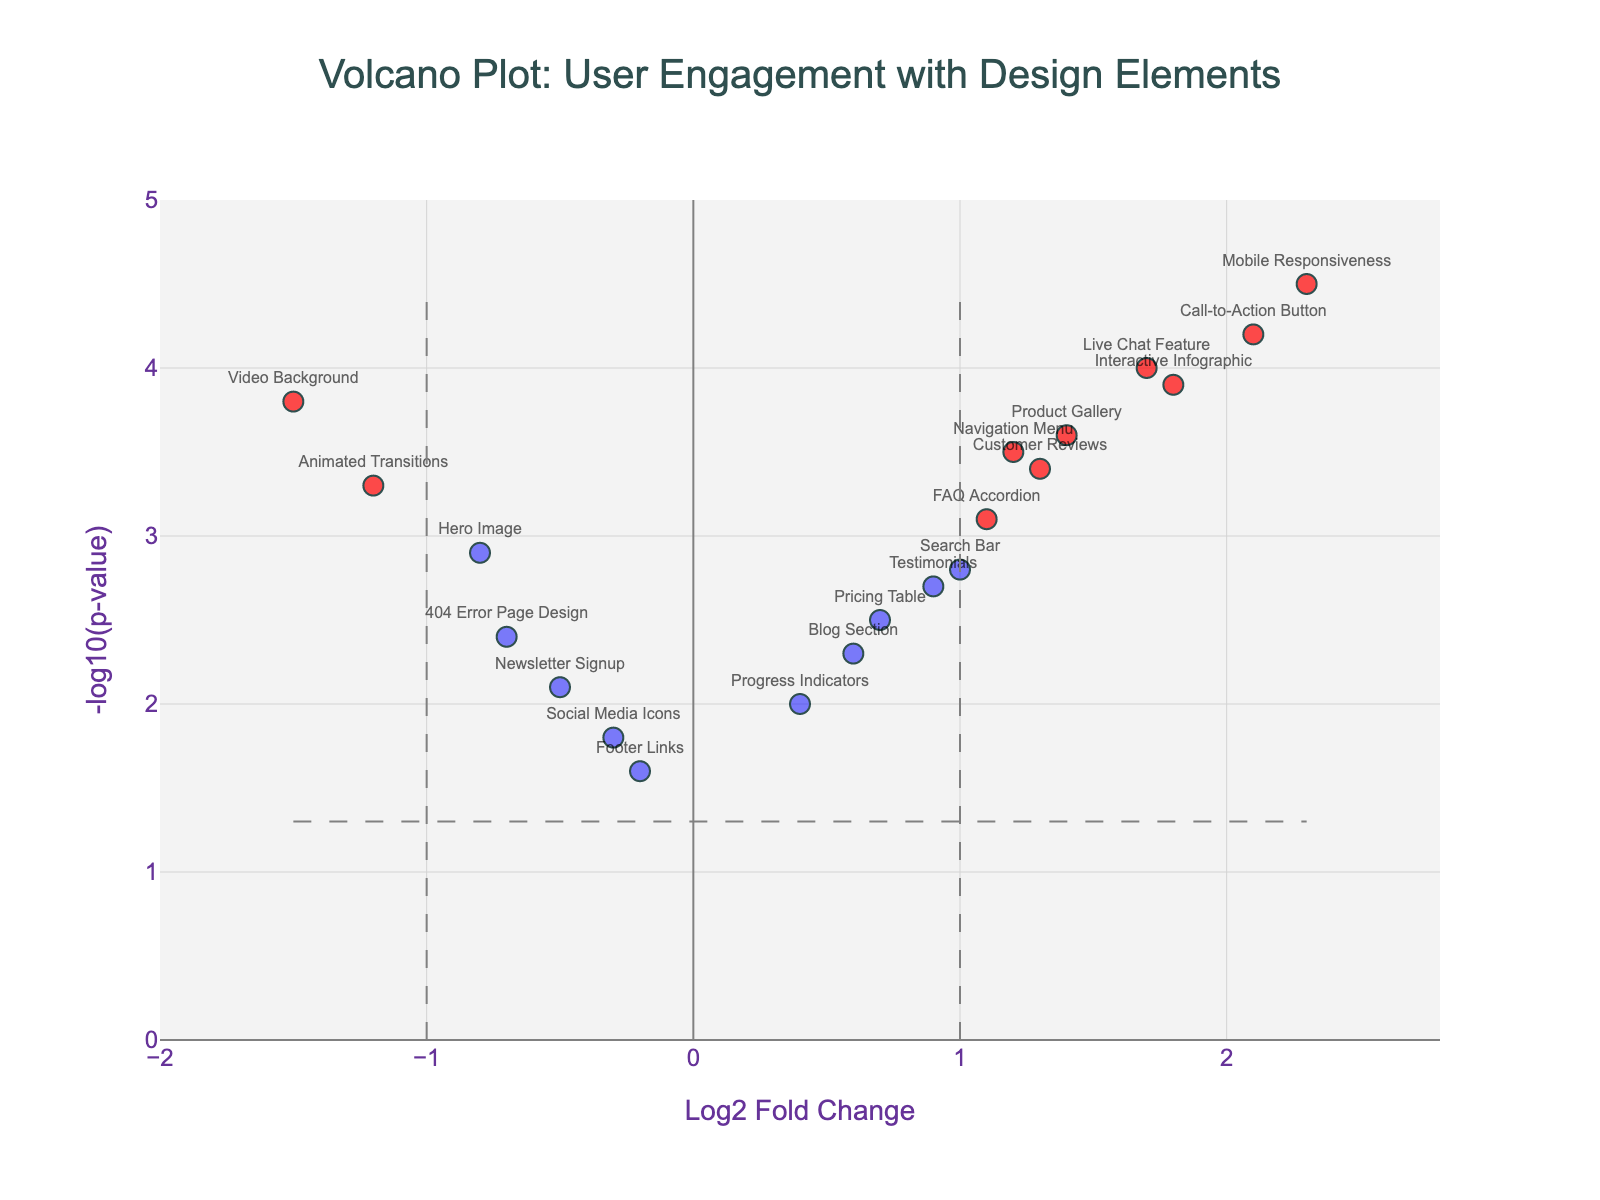What is the title of the figure? The title of the figure is usually placed at the top of the plot. Here, it states "Volcano Plot: User Engagement with Design Elements".
Answer: Volcano Plot: User Engagement with Design Elements What do the x-axis and y-axis represent? The x-axis is labeled as "Log2 Fold Change," representing the extent of change in user engagement, while the y-axis is labeled "-log10(p-value)," representing the significance level of the changes measured.
Answer: Log2 Fold Change and -log10(p-value) Which design feature has the highest positive user engagement, and what are its Log2 Fold Change and Negative Log P-Value values? To find the highest positive user engagement, identify the point with the highest Log2 Fold Change on the x-axis. The "Mobile Responsiveness" feature has the highest value at 2.3. Its -log10(p-value) is 4.5.
Answer: Mobile Responsiveness, 2.3, 4.5 How many design elements show significant effects based on the thresholds indicated? The thresholds are set at Log2 Fold Change > 1 or < -1 and -log10(p-value) > 1.3. Looking at the color-coded markers (red), count the design elements which meet these criteria. There are eight such points ("Navigation Menu", "Call-to-Action Button", "Video Background", "Interactive Infographic", "FAQ Accordion", "Product Gallery", "Live Chat Feature", "Customer Reviews", "Mobile Responsiveness", and "Animated Transitions").
Answer: 9 Which feature has the most negative user engagement effect? Identify the point with the lowest Log2 Fold Change on the x-axis. The "Video Background" feature has the lowest value at -1.5.
Answer: Video Background How many features have a Log2 Fold Change greater than 1.0? Count the number of points that are located to the right of the vertical threshold line at Log2 Fold Change = 1.0. There are seven such points ("Call-to-Action Button", "Interactive Infographic", "FAQ Accordion", "Product Gallery", "Live Chat Feature", "Customer Reviews", and "Mobile Responsiveness").
Answer: 7 Compare the significance of user engagement between "Hero Image" and "Live Chat Feature". Which has a higher significance and by how much? Look at the y-axis values for both features. "Hero Image" has a -log10(p-value) of 2.9 while "Live Chat Feature" has a -log10(p-value) of 4.0. Thus, "Live Chat Feature" has higher significance. The difference in significance is 4.0 - 2.9 = 1.1.
Answer: Live Chat Feature, 1.1 Which features fall into the quadrant indicating negative effects and high significance? To fall in the quadrant with negative effects and high significance, features should have Log2 Fold Change < -1 and -log10(p-value) > 1.3. The only feature meeting these criteria is "Video Background" (-1.5, 3.8).
Answer: Video Background What is the horizontal threshold value for significance and what does it represent? The horizontal threshold line is at -log10(p-value) = 1.3. This represents the p-value threshold below which we consider the results statistically insignificant.
Answer: 1.3 